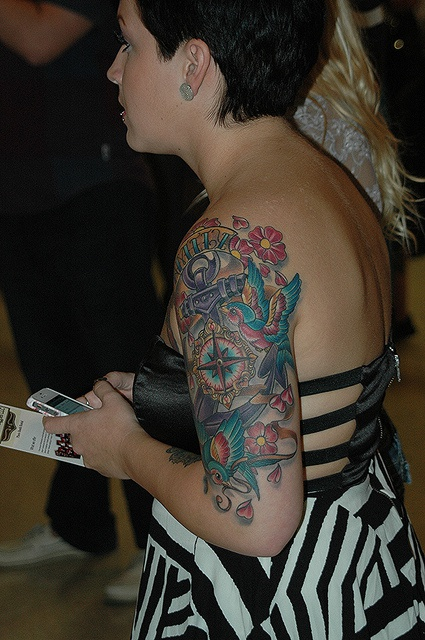Describe the objects in this image and their specific colors. I can see people in maroon, black, and gray tones, people in black, maroon, and gray tones, people in maroon, gray, darkgreen, and black tones, and cell phone in maroon, gray, black, teal, and darkgray tones in this image. 